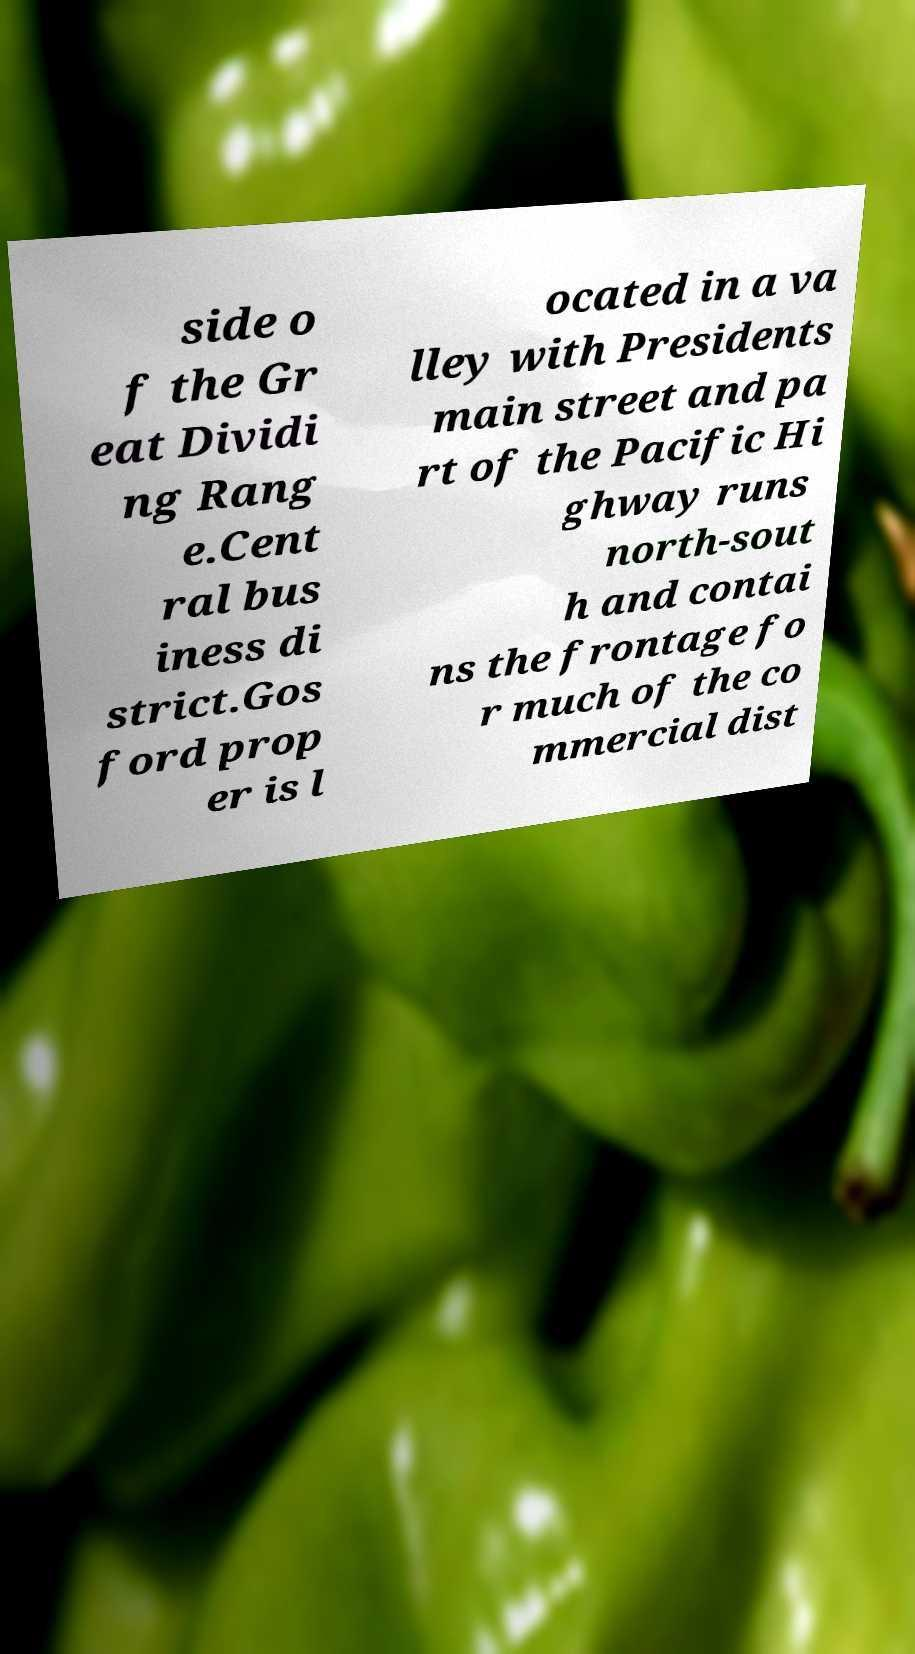Can you accurately transcribe the text from the provided image for me? side o f the Gr eat Dividi ng Rang e.Cent ral bus iness di strict.Gos ford prop er is l ocated in a va lley with Presidents main street and pa rt of the Pacific Hi ghway runs north-sout h and contai ns the frontage fo r much of the co mmercial dist 